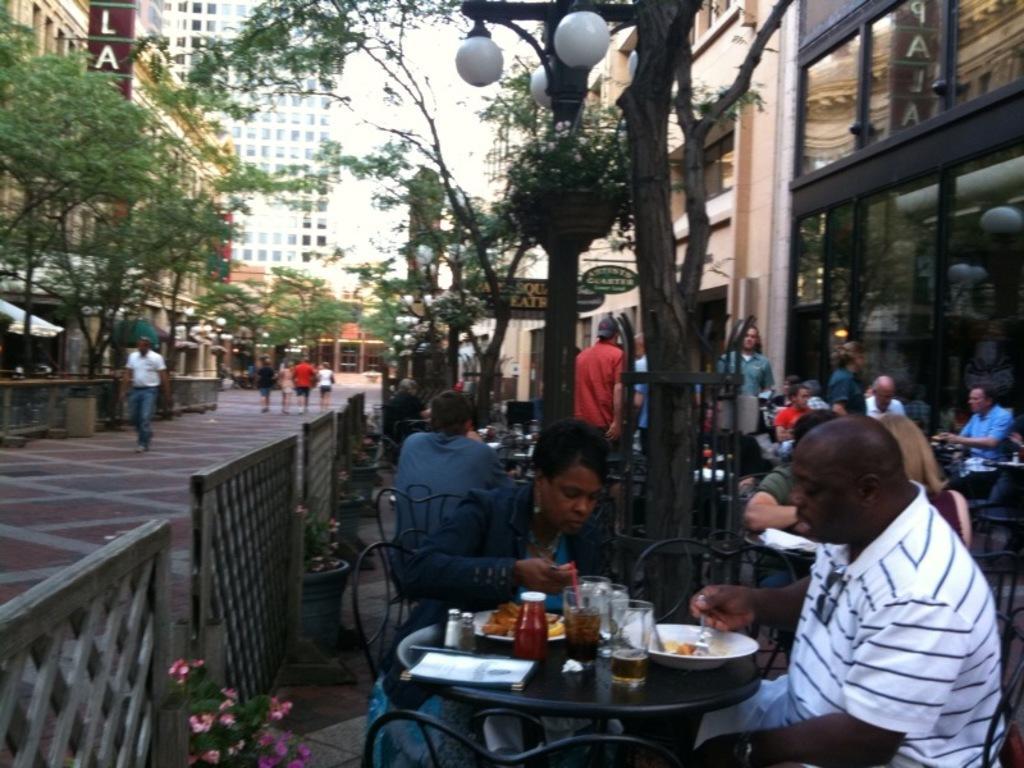In one or two sentences, can you explain what this image depicts? The image is outside of the city. In the image on right side there are group of people sitting on chair in front of a table, on table we can see a book,glass,bowl,plate,food and few people are standing and we can also some trees,lights,buildings and also a hoarding on right side. In middle there are group of people walking, in background there are trees,building,hoarding and sky is on top. 